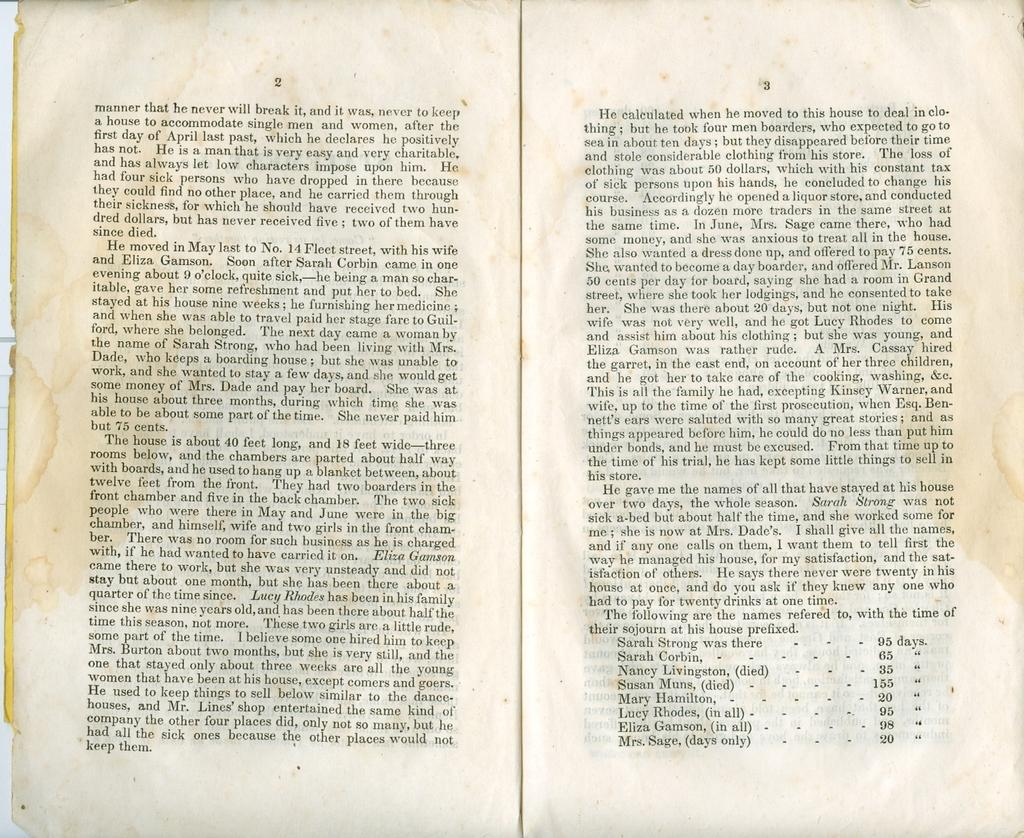<image>
Summarize the visual content of the image. A book is opened to a page that starts with the word manner. 